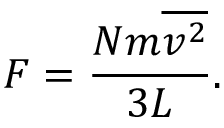Convert formula to latex. <formula><loc_0><loc_0><loc_500><loc_500>F = { \frac { N m { \overline { { v ^ { 2 } } } } } { 3 L } } .</formula> 